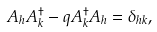<formula> <loc_0><loc_0><loc_500><loc_500>A _ { h } A _ { k } ^ { \dag } - q A _ { k } ^ { \dag } A _ { h } = \delta _ { h k } ,</formula> 